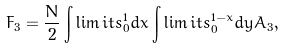<formula> <loc_0><loc_0><loc_500><loc_500>F _ { 3 } = \frac { N } { 2 } \int \lim i t s _ { 0 } ^ { 1 } d x \int \lim i t s _ { 0 } ^ { 1 - x } d y A _ { 3 } ,</formula> 